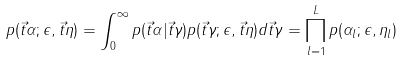<formula> <loc_0><loc_0><loc_500><loc_500>p ( \vec { t } { \alpha } ; \epsilon , \vec { t } { \eta } ) = \int _ { 0 } ^ { \infty } p ( \vec { t } { \alpha } | \vec { t } { \gamma } ) p ( \vec { t } { \gamma } ; \epsilon , \vec { t } { \eta } ) d \vec { t } { \gamma } = \prod _ { l = 1 } ^ { L } p ( \alpha _ { l } ; \epsilon , \eta _ { l } )</formula> 